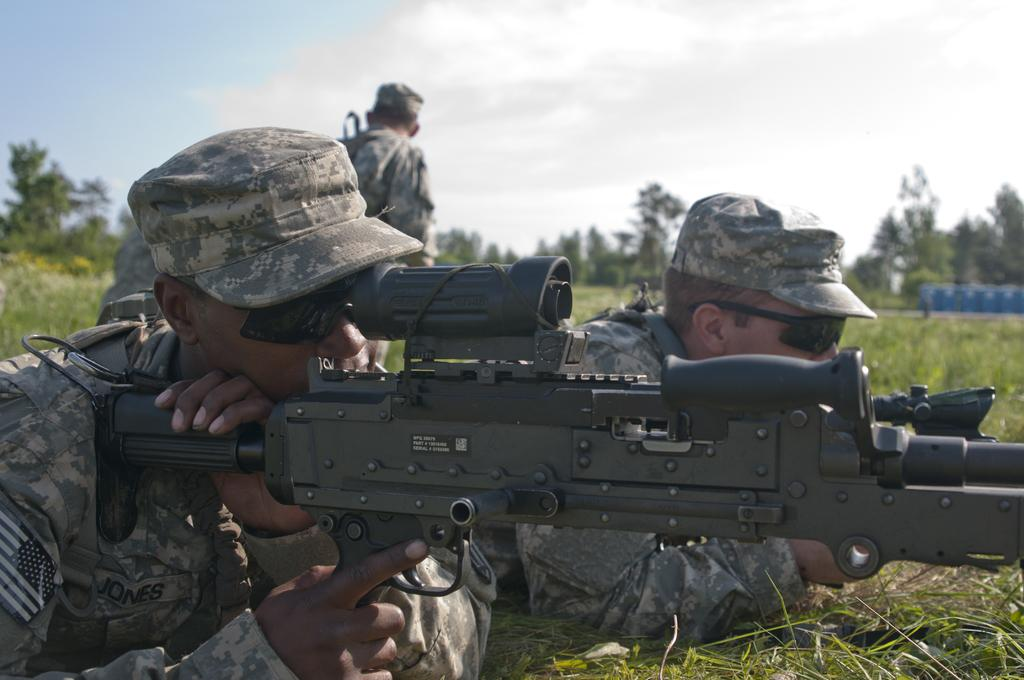How many people are in the image? There are two persons in the image. What are the persons doing in the image? The persons are lying on the ground and holding guns. What type of vegetation is visible at the bottom of the image? There is green grass at the bottom of the image. What can be seen in the background of the image? There are trees in the background of the image. What is visible at the top of the image? The sky is visible at the top of the image. What type of beef is being cooked in the image? There is no beef or any cooking activity present in the image. Who is the father of the person lying on the ground in the image? There is no information about the persons' family relationships in the image. 